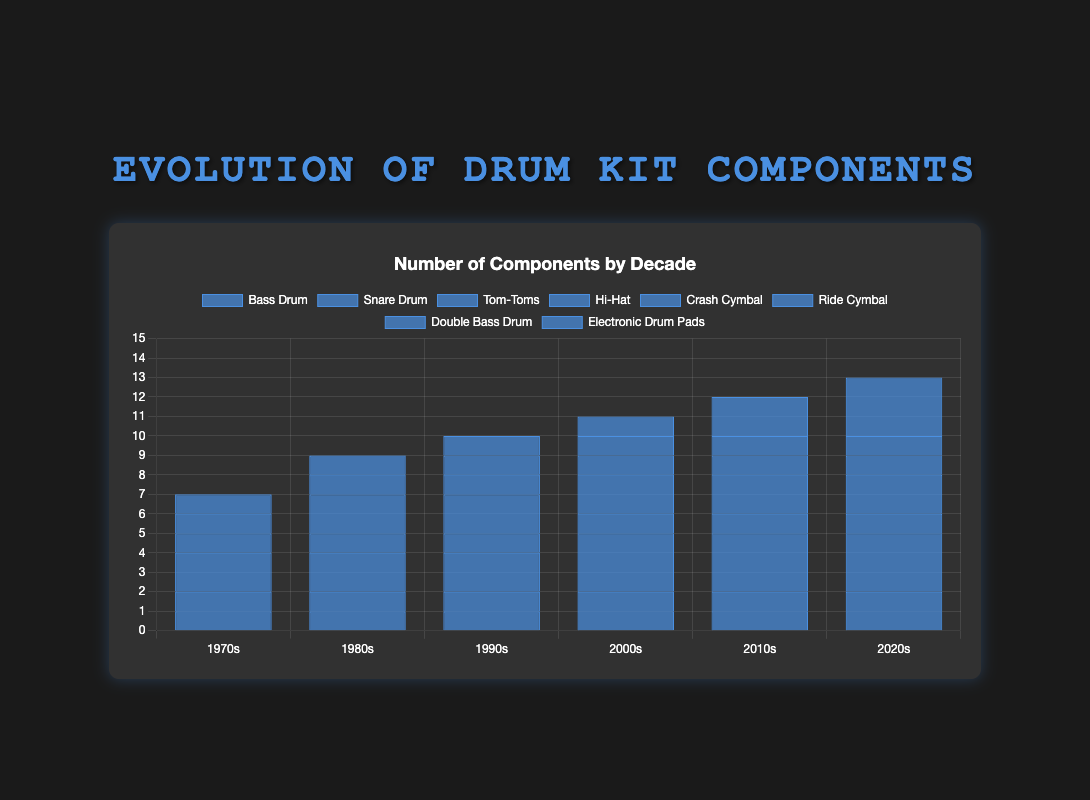How many components were there in the 1970s? There are 8 possible components listed for the 1970s: Bass Drum, Snare Drum, Tom-Toms, Hi-Hat, Crash Cymbal, Ride Cymbal, Double Bass Drum, and Electronic Drum Pads. Summing up the quantities: 1 + 1 + 2 + 1 + 1 + 1 + 0 + 0 = 7
Answer: 7 Which decade saw the introduction of the Double Bass Drum in typical drum kits? The Double Bass Drum first appears in the data in the 1980s. It is at 0 in the 1970s and then at 1 in the 1980s and subsequent decades.
Answer: 1980s By how much did the Tom-Toms count increase between the 1970s and the 2020s? In the 1970s, the count for Tom-Toms is 2 and in the 2020s it is 3. The increase is calculated as 3 - 2 = 1.
Answer: 1 What is the general trend for electronic drum pads from the 1970s to the 2020s? Electronic Drum Pads start at 0 in the 1970s and increase in the following decades with values: 0, 0, 1, 1, 2, and 3. The general trend shows a steady increase over time.
Answer: Increasing How many more Crash Cymbals were used in the 1980s compared to the 1970s? In the 1970s, there was 1 Crash Cymbal, while in the 1980s, there were 2 Crash Cymbals. The difference is calculated as 2 - 1 = 1.
Answer: 1 Did any component(s) remain constant in quantity from the 1970s to the 2020s? Only the Bass Drum, Snare Drum, Hi-Hat, and Ride Cymbal remained constant with a quantity of 1 in each decade.
Answer: Yes Considering only the 1990s, how many components did a typical drum kit have in total? Summing up all the components in the 1990s: Bass Drum (1) + Snare Drum (1) + Tom-Toms (2) + Hi-Hat (1) + Crash Cymbals (2) + Ride Cymbal (1) + Double Bass Drum (1) + Electronic Drum Pads (1) gives 1 + 1 + 2 + 1 + 2 + 1 + 1 + 1 = 10.
Answer: 10 In which decade did the number of Tom-Toms first increase from 2 to 3? The Tom-Toms count increased from 2 to 3 starting in the 2000s, as it was 2 in the 1990s and then 3 from the 2000s onward.
Answer: 2000s What is the difference in the number of Tom-Toms between the decades with the highest and lowest quantities? The highest number of Tom-Toms is 3 (in the 2000s, 2010s, and 2020s) and the lowest is 2 (in the 1970s, 1980s, and 1990s). The difference is 3 - 2 = 1.
Answer: 1 Which component had no presence in the 1970s but gradually increased till the 2020s? The Electronic Drum Pads had no presence in the 1970s (0), then appeared and gradually increased in number over the decades till it reached 3 in the 2020s.
Answer: Electronic Drum Pads 